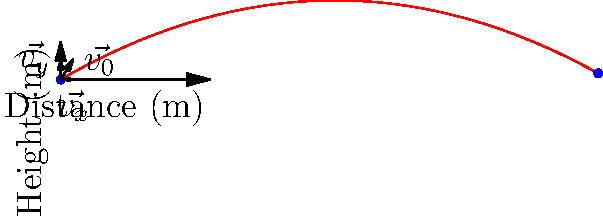In a shooting incident, a bullet is fired with an initial velocity of 50 m/s at an angle of 30° above the horizontal. Using vector components, calculate the maximum height reached by the bullet and the total horizontal distance traveled before it hits the ground. Assume no air resistance and use g = 9.8 m/s². To solve this problem, we'll use vector components and projectile motion equations:

1. Decompose the initial velocity into x and y components:
   $v_{0x} = v_0 \cos \theta = 50 \cos 30° = 43.3$ m/s
   $v_{0y} = v_0 \sin \theta = 50 \sin 30° = 25$ m/s

2. Calculate the time to reach maximum height:
   At max height, $v_y = 0$
   $v_y = v_{0y} - gt$
   $0 = 25 - 9.8t$
   $t = 25 / 9.8 = 2.55$ s

3. Calculate the maximum height:
   $y_{max} = v_{0y}t - \frac{1}{2}gt^2$
   $y_{max} = 25(2.55) - \frac{1}{2}(9.8)(2.55)^2 = 15.9$ m

4. Calculate the total time of flight:
   Total time = 2 × time to max height = 2(2.55) = 5.1 s

5. Calculate the horizontal distance:
   $x = v_{0x}t = 43.3(5.1) = 220.8$ m

Therefore, the maximum height reached is 15.9 m, and the total horizontal distance traveled is 220.8 m.
Answer: Maximum height: 15.9 m; Horizontal distance: 220.8 m 